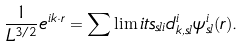Convert formula to latex. <formula><loc_0><loc_0><loc_500><loc_500>\frac { 1 } { L ^ { 3 / 2 } } e ^ { i { k } \cdot { r } } = \sum \lim i t s _ { s { l } i } d _ { { k } , s { l } } ^ { i } \psi ^ { i } _ { { s { l } } } ( { r } ) .</formula> 